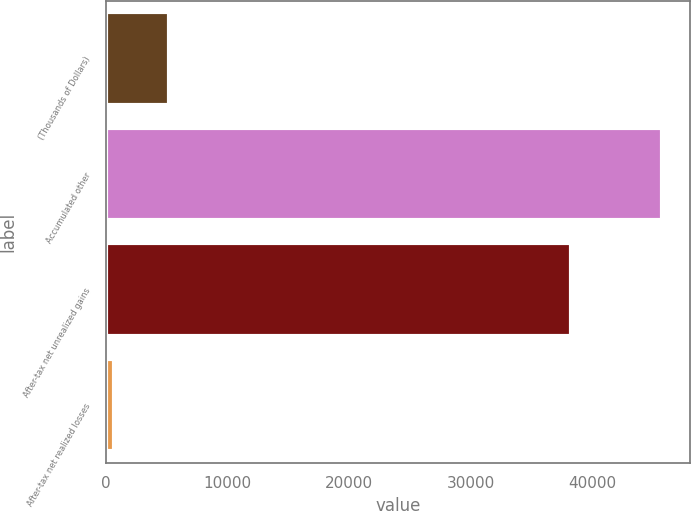Convert chart. <chart><loc_0><loc_0><loc_500><loc_500><bar_chart><fcel>(Thousands of Dollars)<fcel>Accumulated other<fcel>After-tax net unrealized gains<fcel>After-tax net realized losses<nl><fcel>5157<fcel>45738<fcel>38292<fcel>648<nl></chart> 